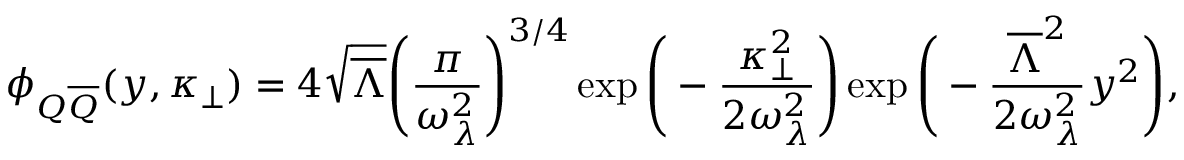Convert formula to latex. <formula><loc_0><loc_0><loc_500><loc_500>\phi _ { Q \overline { Q } } ( y , \kappa _ { \bot } ) = 4 \sqrt { \overline { \Lambda } } \left ( { \frac { \pi } { \omega _ { \lambda } ^ { 2 } } } \right ) ^ { 3 / 4 } \exp \left ( - { \frac { \kappa _ { \bot } ^ { 2 } } { 2 \omega _ { \lambda } ^ { 2 } } } \right ) \exp \left ( - { \frac { \overline { \Lambda } ^ { 2 } } { 2 \omega _ { \lambda } ^ { 2 } } } y ^ { 2 } \right ) ,</formula> 